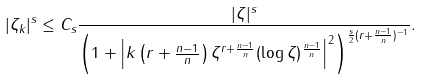Convert formula to latex. <formula><loc_0><loc_0><loc_500><loc_500>| \zeta _ { k } | ^ { s } \leq C _ { s } \frac { | \zeta | ^ { s } } { \left ( 1 + \left | k \left ( r + \frac { n - 1 } { n } \right ) \zeta ^ { r + \frac { n - 1 } { n } } ( \log \zeta ) ^ { \frac { n - 1 } { n } } \right | ^ { 2 } \right ) ^ { \frac { s } { 2 } ( r + \frac { n - 1 } { n } ) ^ { - 1 } } } .</formula> 